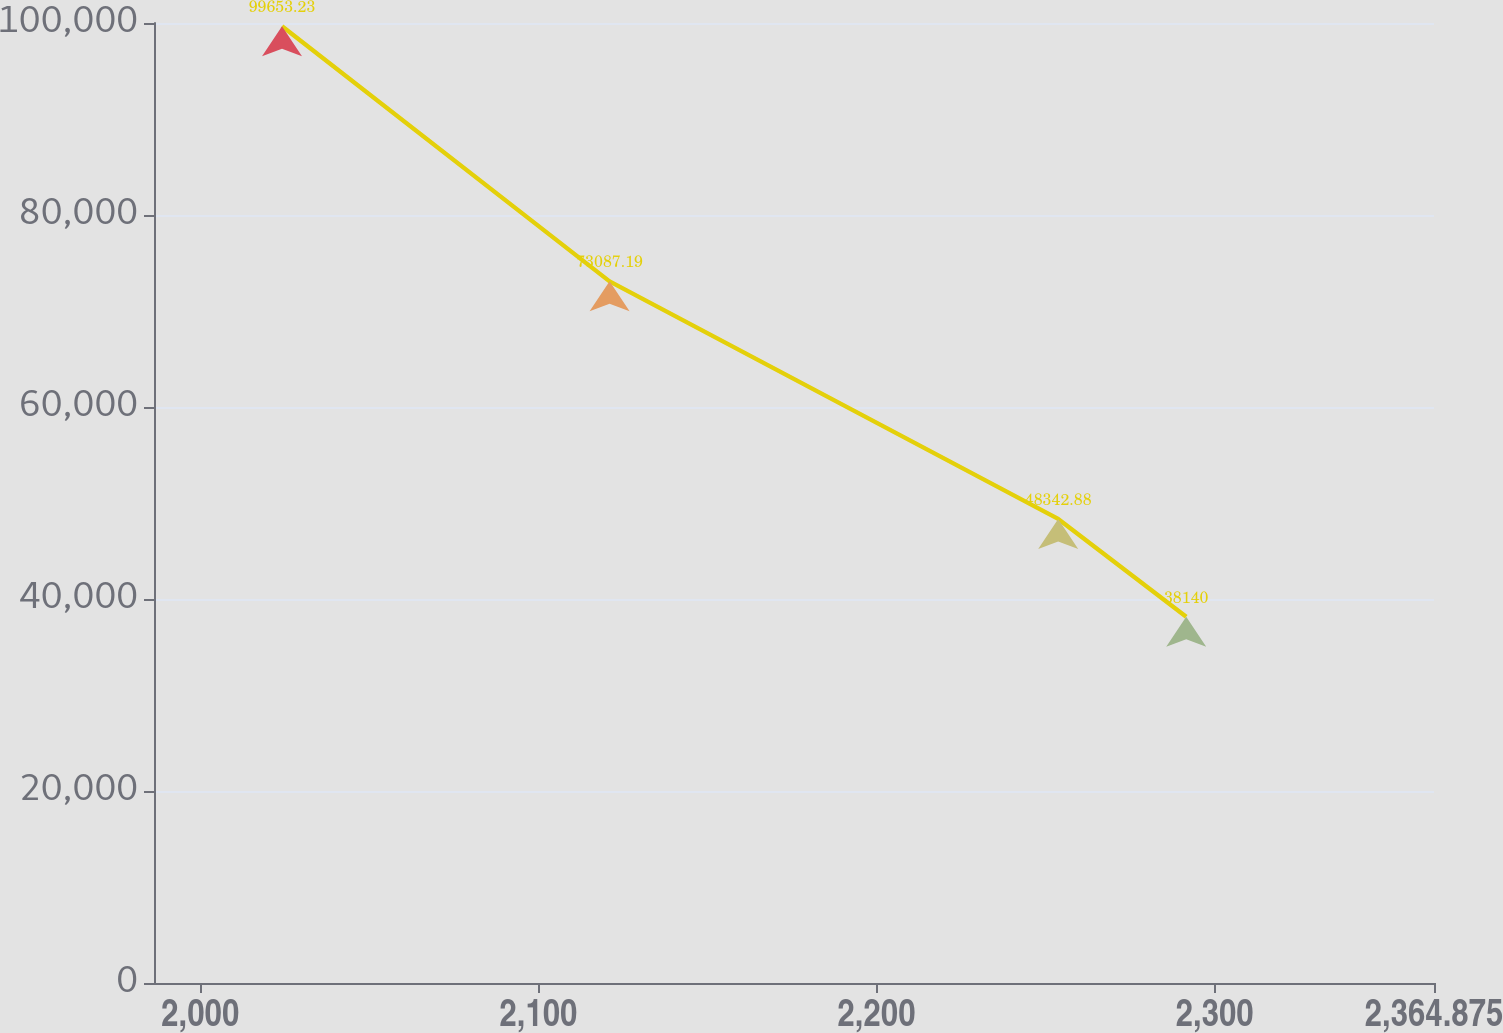Convert chart. <chart><loc_0><loc_0><loc_500><loc_500><line_chart><ecel><fcel>Unnamed: 1<nl><fcel>2024.18<fcel>99653.2<nl><fcel>2121.06<fcel>73087.2<nl><fcel>2253.73<fcel>48342.9<nl><fcel>2291.59<fcel>38140<nl><fcel>2402.73<fcel>16851.6<nl></chart> 